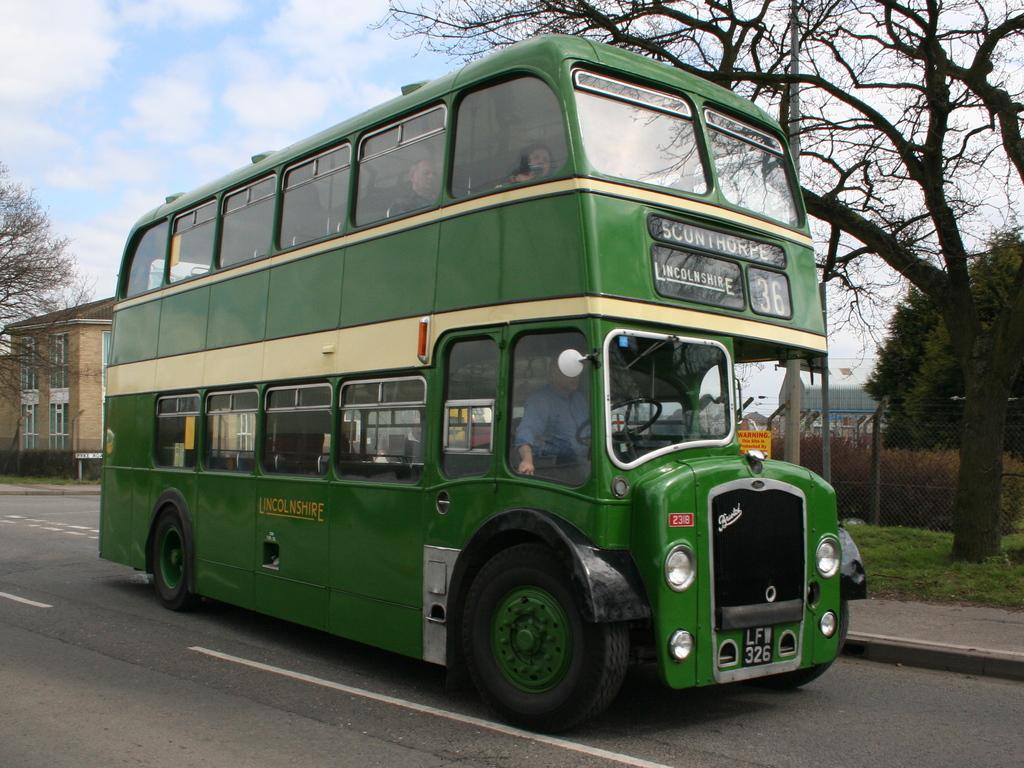<image>
Write a terse but informative summary of the picture. Some people are in the Lincolnshire green bus heading Sconthorpe. 